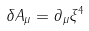Convert formula to latex. <formula><loc_0><loc_0><loc_500><loc_500>\delta A _ { \mu } = \partial _ { \mu } \xi ^ { 4 }</formula> 